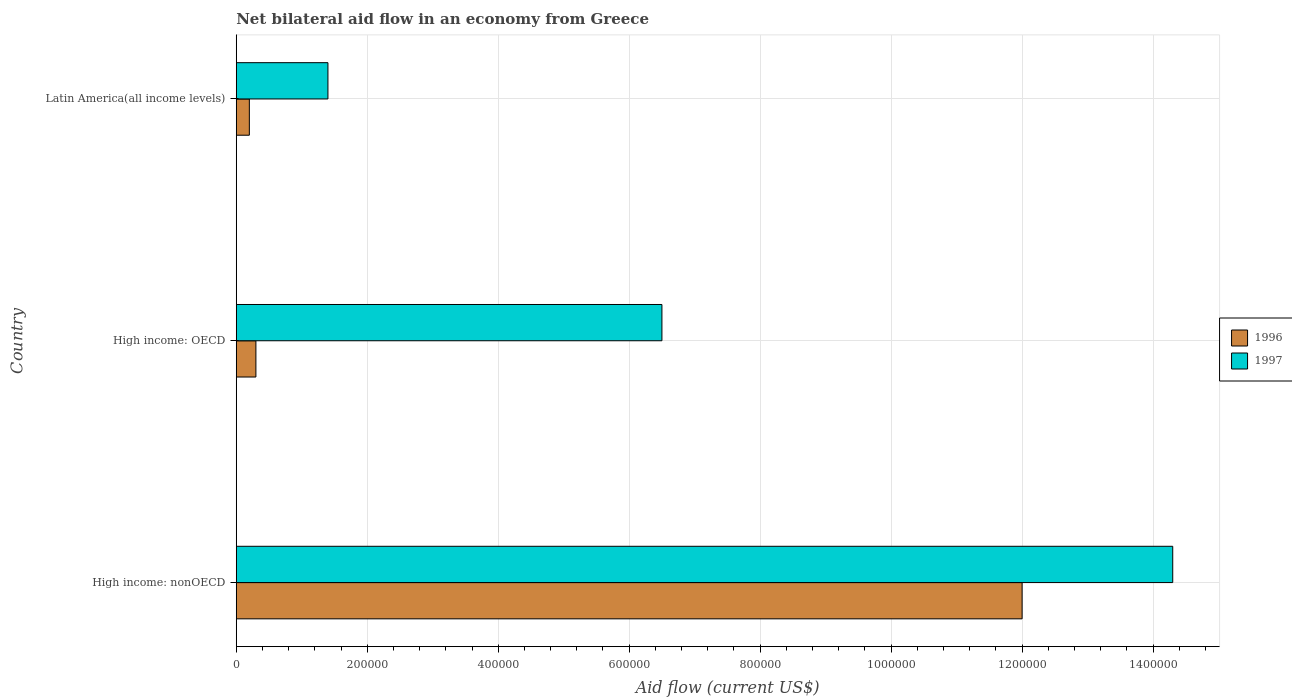Are the number of bars per tick equal to the number of legend labels?
Offer a terse response. Yes. Are the number of bars on each tick of the Y-axis equal?
Provide a succinct answer. Yes. What is the label of the 2nd group of bars from the top?
Your answer should be very brief. High income: OECD. What is the net bilateral aid flow in 1997 in High income: nonOECD?
Make the answer very short. 1.43e+06. Across all countries, what is the maximum net bilateral aid flow in 1996?
Your response must be concise. 1.20e+06. In which country was the net bilateral aid flow in 1996 maximum?
Your answer should be very brief. High income: nonOECD. In which country was the net bilateral aid flow in 1997 minimum?
Provide a succinct answer. Latin America(all income levels). What is the total net bilateral aid flow in 1996 in the graph?
Offer a very short reply. 1.25e+06. What is the difference between the net bilateral aid flow in 1997 in High income: nonOECD and that in Latin America(all income levels)?
Offer a very short reply. 1.29e+06. What is the difference between the net bilateral aid flow in 1997 in Latin America(all income levels) and the net bilateral aid flow in 1996 in High income: nonOECD?
Your response must be concise. -1.06e+06. What is the average net bilateral aid flow in 1996 per country?
Your answer should be very brief. 4.17e+05. In how many countries, is the net bilateral aid flow in 1996 greater than 800000 US$?
Give a very brief answer. 1. Is the net bilateral aid flow in 1997 in High income: OECD less than that in High income: nonOECD?
Ensure brevity in your answer.  Yes. What is the difference between the highest and the second highest net bilateral aid flow in 1997?
Offer a terse response. 7.80e+05. What is the difference between the highest and the lowest net bilateral aid flow in 1997?
Your answer should be compact. 1.29e+06. In how many countries, is the net bilateral aid flow in 1996 greater than the average net bilateral aid flow in 1996 taken over all countries?
Ensure brevity in your answer.  1. What does the 2nd bar from the top in High income: nonOECD represents?
Your answer should be very brief. 1996. What does the 2nd bar from the bottom in Latin America(all income levels) represents?
Offer a very short reply. 1997. Are all the bars in the graph horizontal?
Your answer should be very brief. Yes. How many countries are there in the graph?
Your answer should be very brief. 3. Does the graph contain any zero values?
Your answer should be very brief. No. Where does the legend appear in the graph?
Offer a very short reply. Center right. How many legend labels are there?
Ensure brevity in your answer.  2. How are the legend labels stacked?
Your answer should be very brief. Vertical. What is the title of the graph?
Provide a succinct answer. Net bilateral aid flow in an economy from Greece. What is the Aid flow (current US$) of 1996 in High income: nonOECD?
Offer a terse response. 1.20e+06. What is the Aid flow (current US$) in 1997 in High income: nonOECD?
Keep it short and to the point. 1.43e+06. What is the Aid flow (current US$) of 1997 in High income: OECD?
Make the answer very short. 6.50e+05. Across all countries, what is the maximum Aid flow (current US$) in 1996?
Your answer should be very brief. 1.20e+06. Across all countries, what is the maximum Aid flow (current US$) in 1997?
Make the answer very short. 1.43e+06. What is the total Aid flow (current US$) of 1996 in the graph?
Provide a short and direct response. 1.25e+06. What is the total Aid flow (current US$) of 1997 in the graph?
Make the answer very short. 2.22e+06. What is the difference between the Aid flow (current US$) in 1996 in High income: nonOECD and that in High income: OECD?
Make the answer very short. 1.17e+06. What is the difference between the Aid flow (current US$) in 1997 in High income: nonOECD and that in High income: OECD?
Provide a succinct answer. 7.80e+05. What is the difference between the Aid flow (current US$) in 1996 in High income: nonOECD and that in Latin America(all income levels)?
Offer a very short reply. 1.18e+06. What is the difference between the Aid flow (current US$) in 1997 in High income: nonOECD and that in Latin America(all income levels)?
Your answer should be compact. 1.29e+06. What is the difference between the Aid flow (current US$) in 1997 in High income: OECD and that in Latin America(all income levels)?
Your answer should be compact. 5.10e+05. What is the difference between the Aid flow (current US$) of 1996 in High income: nonOECD and the Aid flow (current US$) of 1997 in Latin America(all income levels)?
Offer a very short reply. 1.06e+06. What is the difference between the Aid flow (current US$) in 1996 in High income: OECD and the Aid flow (current US$) in 1997 in Latin America(all income levels)?
Your answer should be compact. -1.10e+05. What is the average Aid flow (current US$) of 1996 per country?
Your response must be concise. 4.17e+05. What is the average Aid flow (current US$) of 1997 per country?
Your answer should be compact. 7.40e+05. What is the difference between the Aid flow (current US$) in 1996 and Aid flow (current US$) in 1997 in High income: nonOECD?
Make the answer very short. -2.30e+05. What is the difference between the Aid flow (current US$) in 1996 and Aid flow (current US$) in 1997 in High income: OECD?
Your answer should be compact. -6.20e+05. What is the difference between the Aid flow (current US$) in 1996 and Aid flow (current US$) in 1997 in Latin America(all income levels)?
Offer a very short reply. -1.20e+05. What is the ratio of the Aid flow (current US$) in 1997 in High income: nonOECD to that in Latin America(all income levels)?
Offer a terse response. 10.21. What is the ratio of the Aid flow (current US$) in 1996 in High income: OECD to that in Latin America(all income levels)?
Provide a short and direct response. 1.5. What is the ratio of the Aid flow (current US$) of 1997 in High income: OECD to that in Latin America(all income levels)?
Offer a terse response. 4.64. What is the difference between the highest and the second highest Aid flow (current US$) of 1996?
Offer a terse response. 1.17e+06. What is the difference between the highest and the second highest Aid flow (current US$) of 1997?
Make the answer very short. 7.80e+05. What is the difference between the highest and the lowest Aid flow (current US$) in 1996?
Your response must be concise. 1.18e+06. What is the difference between the highest and the lowest Aid flow (current US$) in 1997?
Provide a succinct answer. 1.29e+06. 